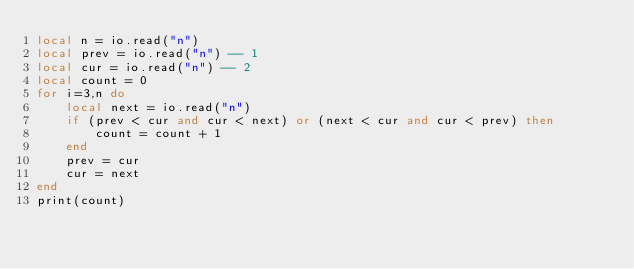Convert code to text. <code><loc_0><loc_0><loc_500><loc_500><_Lua_>local n = io.read("n")
local prev = io.read("n") -- 1
local cur = io.read("n") -- 2
local count = 0
for i=3,n do
    local next = io.read("n")
    if (prev < cur and cur < next) or (next < cur and cur < prev) then
        count = count + 1
    end
    prev = cur
    cur = next
end
print(count)</code> 